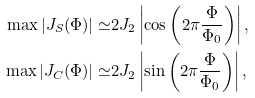Convert formula to latex. <formula><loc_0><loc_0><loc_500><loc_500>\max | J _ { S } ( \Phi ) | \simeq & 2 J _ { 2 } \left | \cos \left ( 2 \pi \frac { \Phi } { \Phi _ { 0 } } \right ) \right | , \\ \max | J _ { C } ( \Phi ) | \simeq & 2 J _ { 2 } \left | \sin \left ( 2 \pi \frac { \Phi } { \Phi _ { 0 } } \right ) \right | ,</formula> 